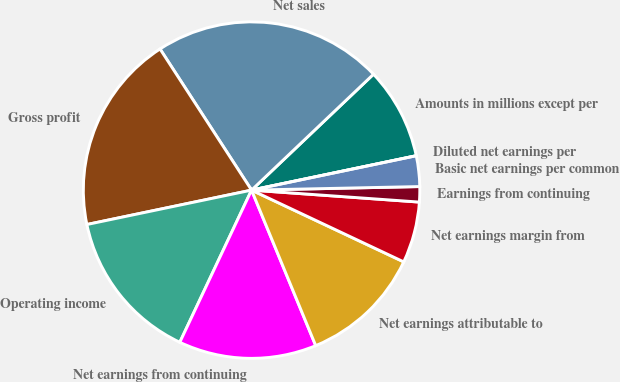Convert chart to OTSL. <chart><loc_0><loc_0><loc_500><loc_500><pie_chart><fcel>Amounts in millions except per<fcel>Net sales<fcel>Gross profit<fcel>Operating income<fcel>Net earnings from continuing<fcel>Net earnings attributable to<fcel>Net earnings margin from<fcel>Earnings from continuing<fcel>Basic net earnings per common<fcel>Diluted net earnings per<nl><fcel>8.82%<fcel>22.06%<fcel>19.12%<fcel>14.71%<fcel>13.24%<fcel>11.76%<fcel>5.88%<fcel>1.47%<fcel>2.94%<fcel>0.0%<nl></chart> 